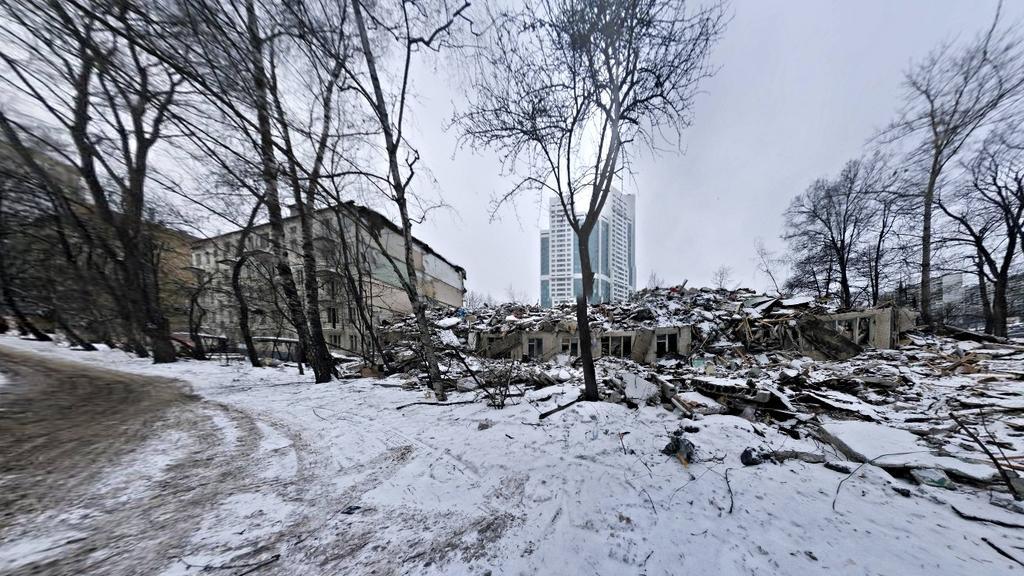Could you give a brief overview of what you see in this image? In this image we can see snow on the ground, trees, collapsed building and windows. In the background there are buildings, trees, windows and sky. 